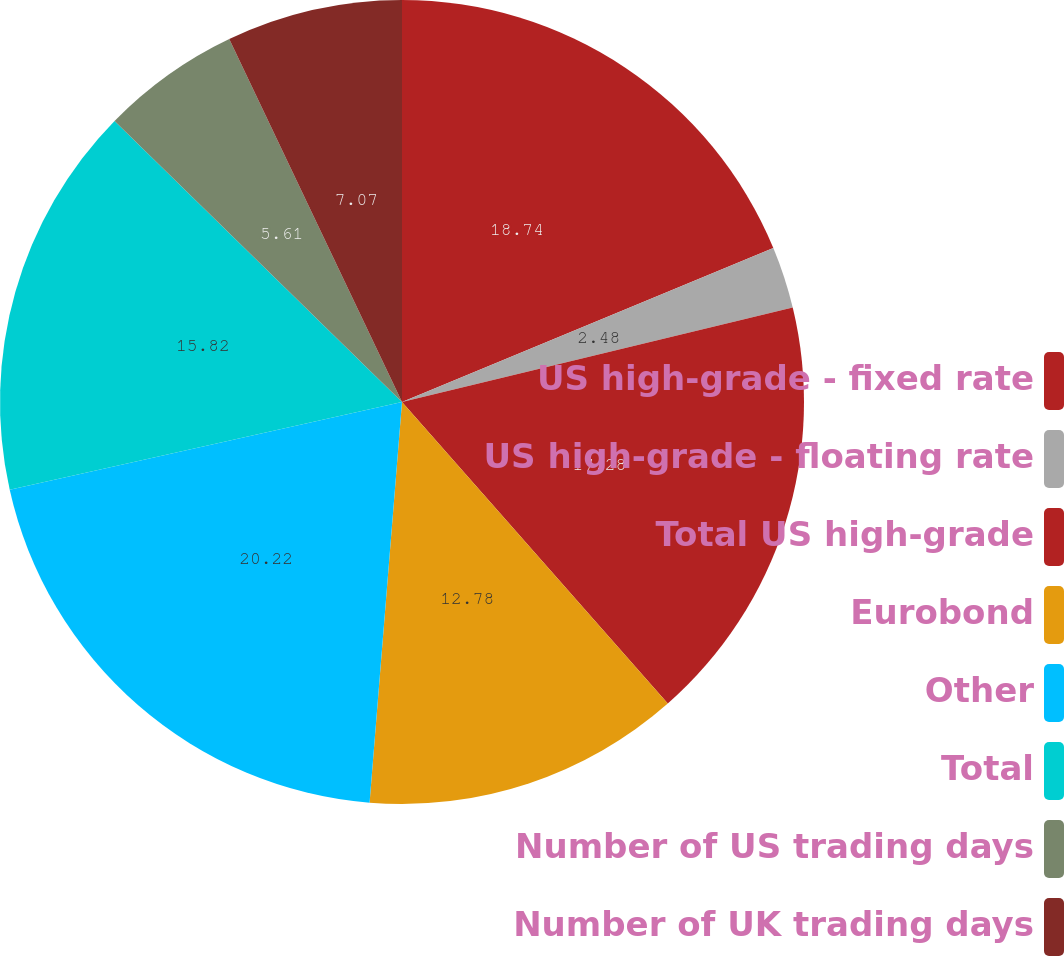<chart> <loc_0><loc_0><loc_500><loc_500><pie_chart><fcel>US high-grade - fixed rate<fcel>US high-grade - floating rate<fcel>Total US high-grade<fcel>Eurobond<fcel>Other<fcel>Total<fcel>Number of US trading days<fcel>Number of UK trading days<nl><fcel>18.74%<fcel>2.48%<fcel>17.28%<fcel>12.78%<fcel>20.21%<fcel>15.82%<fcel>5.61%<fcel>7.07%<nl></chart> 